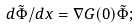Convert formula to latex. <formula><loc_0><loc_0><loc_500><loc_500>d \tilde { \Phi } / d x = \nabla G ( 0 ) \tilde { \Phi } ;</formula> 